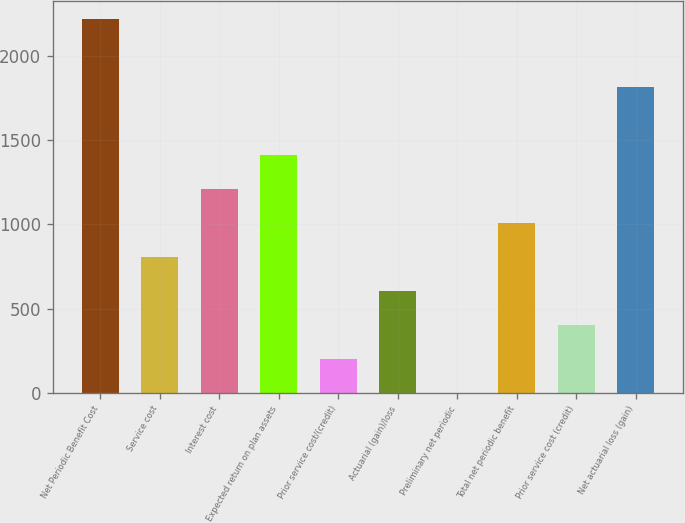<chart> <loc_0><loc_0><loc_500><loc_500><bar_chart><fcel>Net Periodic Benefit Cost<fcel>Service cost<fcel>Interest cost<fcel>Expected return on plan assets<fcel>Prior service cost/(credit)<fcel>Actuarial (gain)/loss<fcel>Preliminary net periodic<fcel>Total net periodic benefit<fcel>Prior service cost (credit)<fcel>Net actuarial loss (gain)<nl><fcel>2215.23<fcel>806.62<fcel>1209.08<fcel>1410.31<fcel>202.93<fcel>605.39<fcel>1.7<fcel>1007.85<fcel>404.16<fcel>1812.77<nl></chart> 